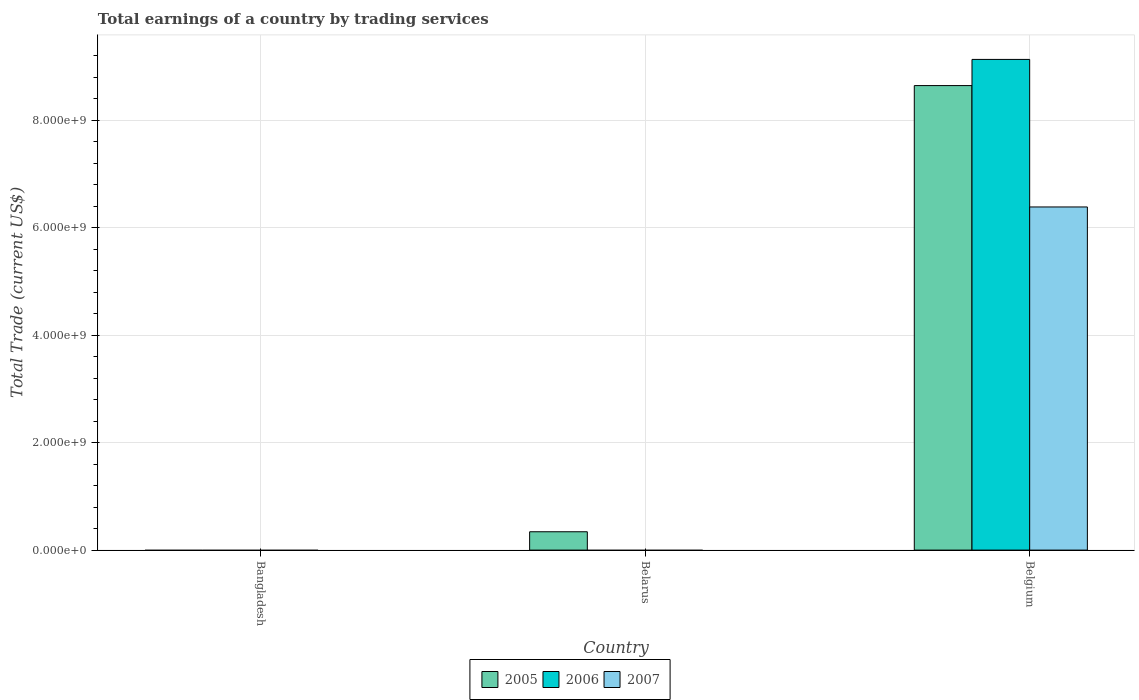Are the number of bars per tick equal to the number of legend labels?
Your answer should be compact. No. Are the number of bars on each tick of the X-axis equal?
Provide a succinct answer. No. In how many cases, is the number of bars for a given country not equal to the number of legend labels?
Offer a terse response. 2. What is the total earnings in 2007 in Belarus?
Provide a short and direct response. 0. Across all countries, what is the maximum total earnings in 2007?
Offer a terse response. 6.39e+09. What is the total total earnings in 2005 in the graph?
Provide a succinct answer. 8.99e+09. What is the difference between the total earnings in 2006 in Belgium and the total earnings in 2007 in Bangladesh?
Give a very brief answer. 9.14e+09. What is the average total earnings in 2005 per country?
Provide a succinct answer. 3.00e+09. What is the difference between the total earnings of/in 2007 and total earnings of/in 2006 in Belgium?
Your response must be concise. -2.75e+09. What is the ratio of the total earnings in 2005 in Belarus to that in Belgium?
Provide a short and direct response. 0.04. What is the difference between the highest and the lowest total earnings in 2005?
Give a very brief answer. 8.65e+09. Is it the case that in every country, the sum of the total earnings in 2006 and total earnings in 2007 is greater than the total earnings in 2005?
Keep it short and to the point. No. How many bars are there?
Give a very brief answer. 4. Are all the bars in the graph horizontal?
Provide a short and direct response. No. How many countries are there in the graph?
Offer a very short reply. 3. What is the difference between two consecutive major ticks on the Y-axis?
Make the answer very short. 2.00e+09. Are the values on the major ticks of Y-axis written in scientific E-notation?
Your answer should be compact. Yes. Does the graph contain any zero values?
Give a very brief answer. Yes. How are the legend labels stacked?
Your answer should be compact. Horizontal. What is the title of the graph?
Offer a very short reply. Total earnings of a country by trading services. What is the label or title of the Y-axis?
Give a very brief answer. Total Trade (current US$). What is the Total Trade (current US$) of 2006 in Bangladesh?
Keep it short and to the point. 0. What is the Total Trade (current US$) of 2005 in Belarus?
Your answer should be very brief. 3.42e+08. What is the Total Trade (current US$) in 2006 in Belarus?
Offer a terse response. 0. What is the Total Trade (current US$) in 2005 in Belgium?
Provide a short and direct response. 8.65e+09. What is the Total Trade (current US$) of 2006 in Belgium?
Your response must be concise. 9.14e+09. What is the Total Trade (current US$) of 2007 in Belgium?
Give a very brief answer. 6.39e+09. Across all countries, what is the maximum Total Trade (current US$) of 2005?
Provide a succinct answer. 8.65e+09. Across all countries, what is the maximum Total Trade (current US$) in 2006?
Provide a short and direct response. 9.14e+09. Across all countries, what is the maximum Total Trade (current US$) in 2007?
Your answer should be compact. 6.39e+09. Across all countries, what is the minimum Total Trade (current US$) in 2005?
Your answer should be compact. 0. Across all countries, what is the minimum Total Trade (current US$) in 2006?
Offer a terse response. 0. What is the total Total Trade (current US$) in 2005 in the graph?
Your answer should be compact. 8.99e+09. What is the total Total Trade (current US$) of 2006 in the graph?
Ensure brevity in your answer.  9.14e+09. What is the total Total Trade (current US$) of 2007 in the graph?
Offer a terse response. 6.39e+09. What is the difference between the Total Trade (current US$) in 2005 in Belarus and that in Belgium?
Make the answer very short. -8.31e+09. What is the difference between the Total Trade (current US$) in 2005 in Belarus and the Total Trade (current US$) in 2006 in Belgium?
Make the answer very short. -8.79e+09. What is the difference between the Total Trade (current US$) of 2005 in Belarus and the Total Trade (current US$) of 2007 in Belgium?
Provide a short and direct response. -6.05e+09. What is the average Total Trade (current US$) in 2005 per country?
Your answer should be very brief. 3.00e+09. What is the average Total Trade (current US$) of 2006 per country?
Make the answer very short. 3.05e+09. What is the average Total Trade (current US$) in 2007 per country?
Your response must be concise. 2.13e+09. What is the difference between the Total Trade (current US$) in 2005 and Total Trade (current US$) in 2006 in Belgium?
Provide a succinct answer. -4.87e+08. What is the difference between the Total Trade (current US$) of 2005 and Total Trade (current US$) of 2007 in Belgium?
Give a very brief answer. 2.26e+09. What is the difference between the Total Trade (current US$) in 2006 and Total Trade (current US$) in 2007 in Belgium?
Offer a terse response. 2.75e+09. What is the ratio of the Total Trade (current US$) of 2005 in Belarus to that in Belgium?
Your response must be concise. 0.04. What is the difference between the highest and the lowest Total Trade (current US$) in 2005?
Provide a succinct answer. 8.65e+09. What is the difference between the highest and the lowest Total Trade (current US$) of 2006?
Keep it short and to the point. 9.14e+09. What is the difference between the highest and the lowest Total Trade (current US$) of 2007?
Provide a succinct answer. 6.39e+09. 